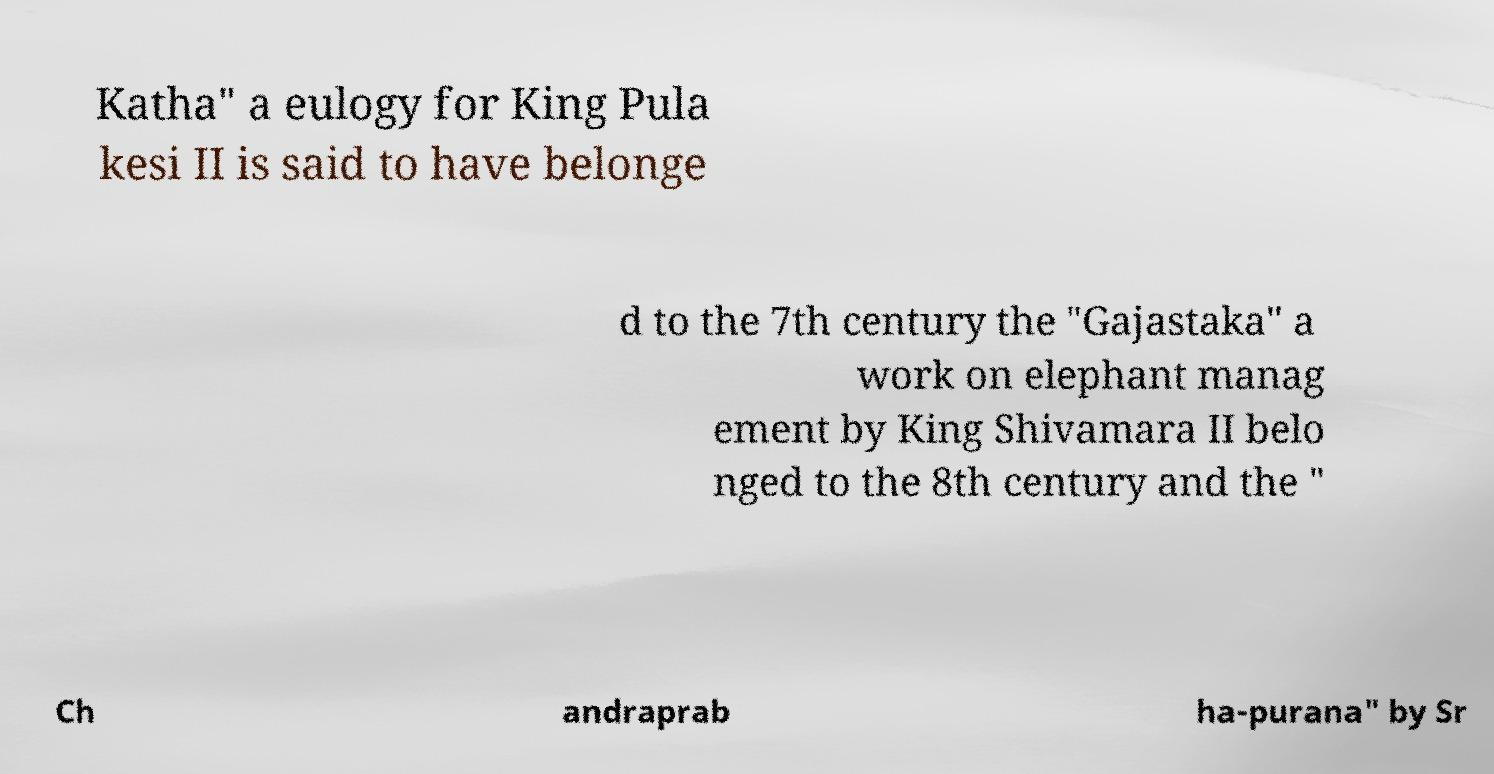Can you read and provide the text displayed in the image?This photo seems to have some interesting text. Can you extract and type it out for me? Katha" a eulogy for King Pula kesi II is said to have belonge d to the 7th century the "Gajastaka" a work on elephant manag ement by King Shivamara II belo nged to the 8th century and the " Ch andraprab ha-purana" by Sr 